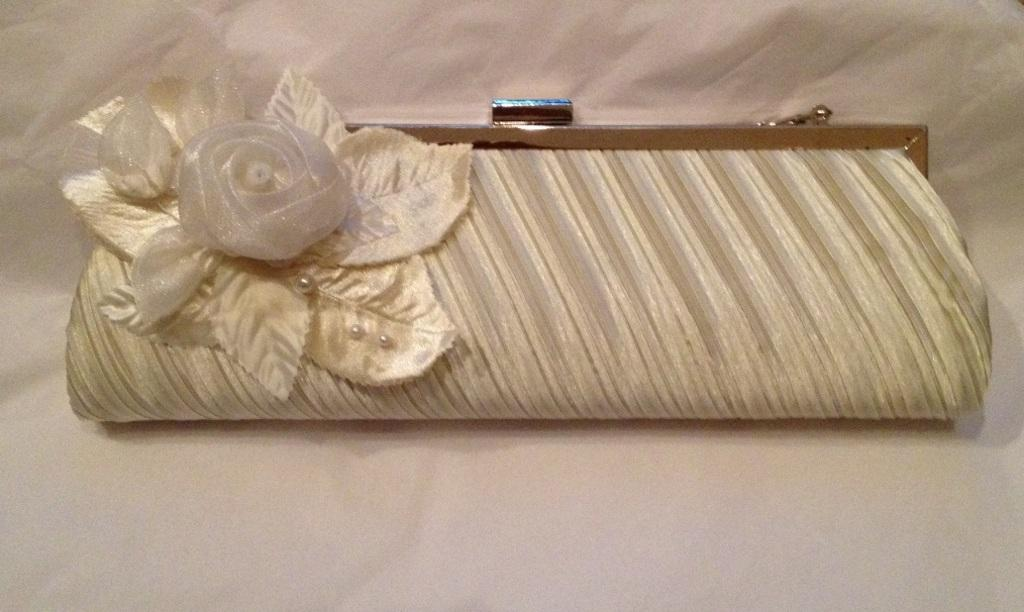What object is present in the image? There is a wallet in the image. What design or decoration is on the wallet? The wallet has a flower on it. What color is the surface the wallet is placed on? The surface the wallet is on is white. How many pieces of fruit are in the wallet? There are no pieces of fruit present in the image, let alone in the wallet. 